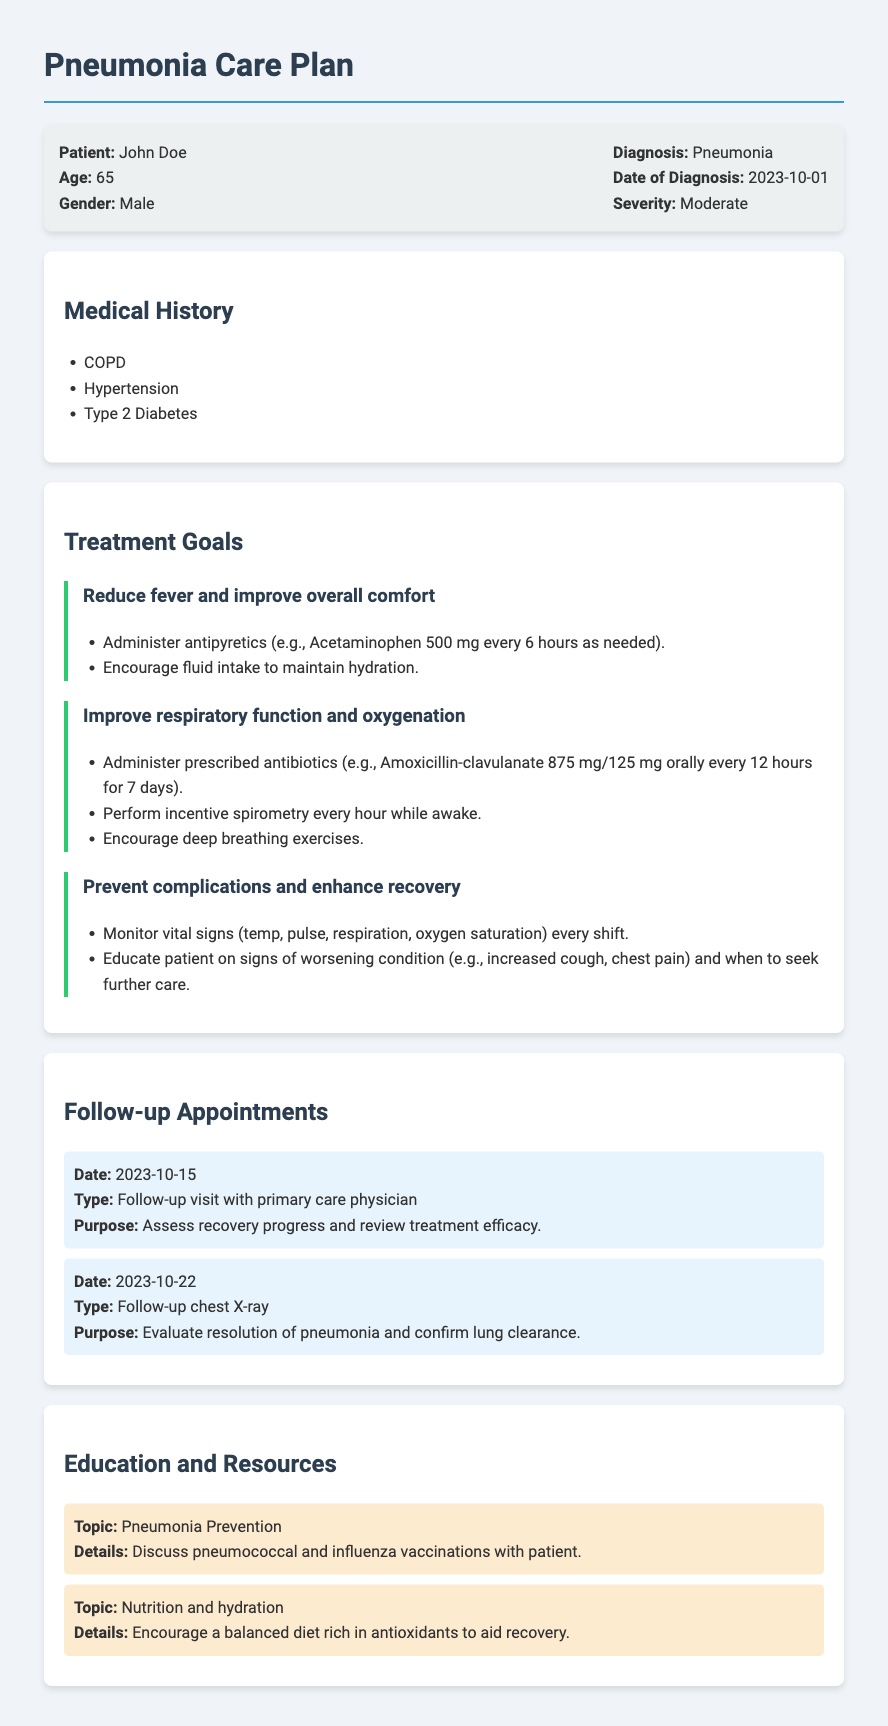What is the patient's name? The patient's name is listed at the beginning of the document in the patient info section.
Answer: John Doe What is the date of diagnosis? The date of diagnosis is mentioned under the patient information section alongside the diagnosis.
Answer: 2023-10-01 What is the prescribed antibiotic? The antibiotic is detailed in the treatment goals for improving respiratory function and oxygenation.
Answer: Amoxicillin-clavulanate 875 mg/125 mg How often should antipyretics be administered? The frequency of administering antipyretics is specified in the treatment goals for reducing fever and comfort.
Answer: every 6 hours What is the purpose of the follow-up visit on October 15? The purpose of the follow-up visit is stated within the follow-up appointments section.
Answer: Assess recovery progress and review treatment efficacy Which vaccinations are discussed for pneumonia prevention? The topic of pneumonia prevention includes specific vaccinations mentioned in the education section.
Answer: pneumococcal and influenza vaccinations How many days should the prescribed antibiotics be taken? The duration of antibiotic treatment is provided in the treatment goals for improving respiratory function.
Answer: 7 days What should the patient be educated on regarding vital signs? The education on monitoring vital signs is found under the prevention of complications to enhance recovery.
Answer: every shift What age is the patient? The age is provided in the patient information section at the beginning of the document.
Answer: 65 